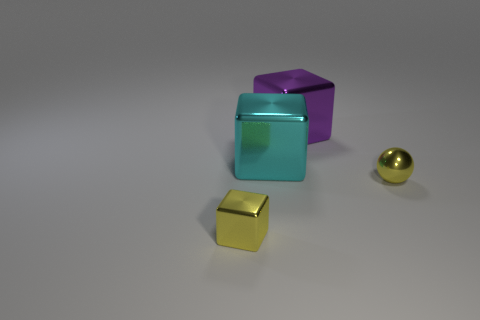Add 4 big purple cubes. How many objects exist? 8 Subtract all blocks. How many objects are left? 1 Add 2 large purple cubes. How many large purple cubes exist? 3 Subtract 0 red cylinders. How many objects are left? 4 Subtract all yellow spheres. Subtract all tiny shiny cubes. How many objects are left? 2 Add 3 tiny yellow balls. How many tiny yellow balls are left? 4 